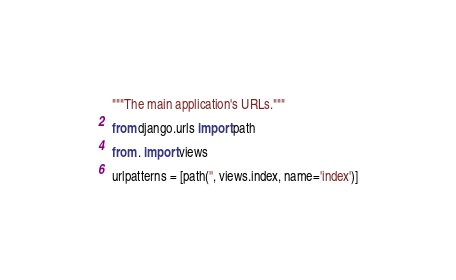<code> <loc_0><loc_0><loc_500><loc_500><_Python_>"""The main application's URLs."""

from django.urls import path

from . import views

urlpatterns = [path('', views.index, name='index')]
</code> 